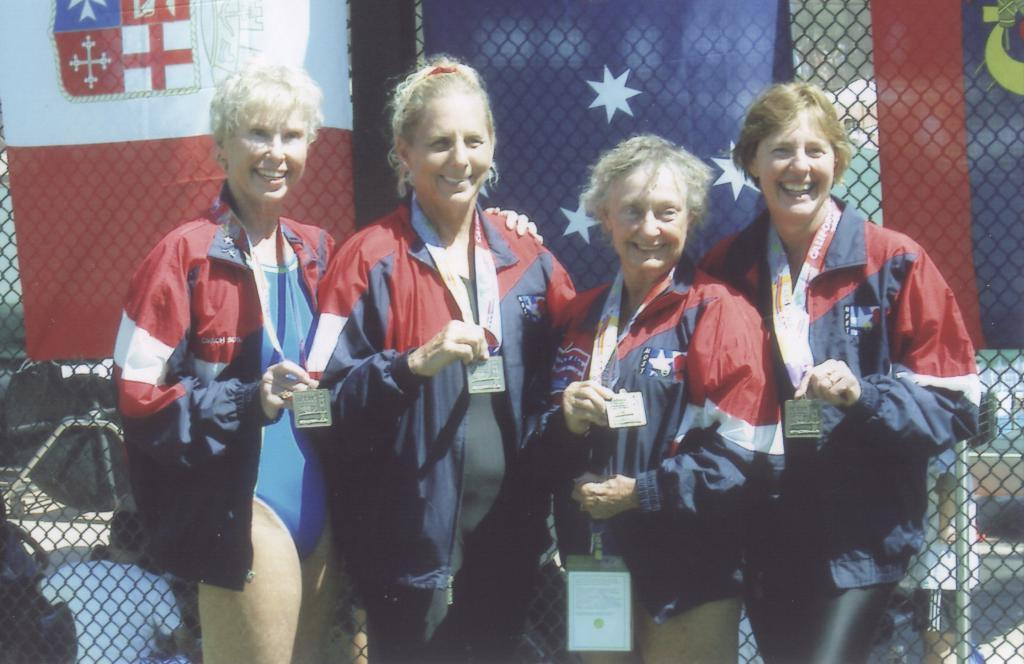How many people are in the image? There are people in the image, but the exact number is not specified. What are the people doing in the image? The people are standing and smiling in the image. What can be seen in the background of the image? There is a fencing in the background of the image. What type of animals can be seen in the crowd at the zoo in the image? There is no mention of a crowd or a zoo in the image, so it is not possible to answer that question. 